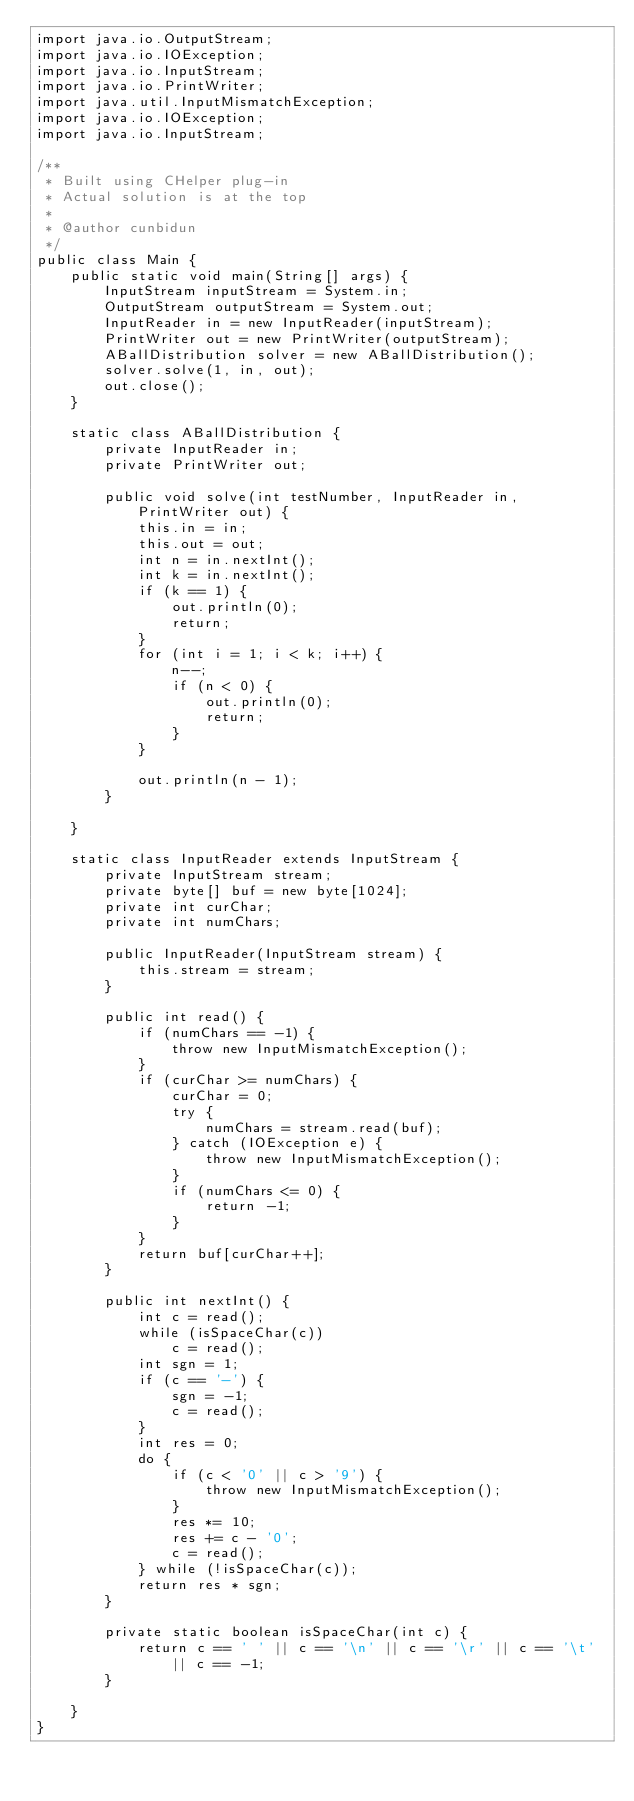<code> <loc_0><loc_0><loc_500><loc_500><_Java_>import java.io.OutputStream;
import java.io.IOException;
import java.io.InputStream;
import java.io.PrintWriter;
import java.util.InputMismatchException;
import java.io.IOException;
import java.io.InputStream;

/**
 * Built using CHelper plug-in
 * Actual solution is at the top
 *
 * @author cunbidun
 */
public class Main {
    public static void main(String[] args) {
        InputStream inputStream = System.in;
        OutputStream outputStream = System.out;
        InputReader in = new InputReader(inputStream);
        PrintWriter out = new PrintWriter(outputStream);
        ABallDistribution solver = new ABallDistribution();
        solver.solve(1, in, out);
        out.close();
    }

    static class ABallDistribution {
        private InputReader in;
        private PrintWriter out;

        public void solve(int testNumber, InputReader in, PrintWriter out) {
            this.in = in;
            this.out = out;
            int n = in.nextInt();
            int k = in.nextInt();
            if (k == 1) {
                out.println(0);
                return;
            }
            for (int i = 1; i < k; i++) {
                n--;
                if (n < 0) {
                    out.println(0);
                    return;
                }
            }

            out.println(n - 1);
        }

    }

    static class InputReader extends InputStream {
        private InputStream stream;
        private byte[] buf = new byte[1024];
        private int curChar;
        private int numChars;

        public InputReader(InputStream stream) {
            this.stream = stream;
        }

        public int read() {
            if (numChars == -1) {
                throw new InputMismatchException();
            }
            if (curChar >= numChars) {
                curChar = 0;
                try {
                    numChars = stream.read(buf);
                } catch (IOException e) {
                    throw new InputMismatchException();
                }
                if (numChars <= 0) {
                    return -1;
                }
            }
            return buf[curChar++];
        }

        public int nextInt() {
            int c = read();
            while (isSpaceChar(c))
                c = read();
            int sgn = 1;
            if (c == '-') {
                sgn = -1;
                c = read();
            }
            int res = 0;
            do {
                if (c < '0' || c > '9') {
                    throw new InputMismatchException();
                }
                res *= 10;
                res += c - '0';
                c = read();
            } while (!isSpaceChar(c));
            return res * sgn;
        }

        private static boolean isSpaceChar(int c) {
            return c == ' ' || c == '\n' || c == '\r' || c == '\t' || c == -1;
        }

    }
}

</code> 